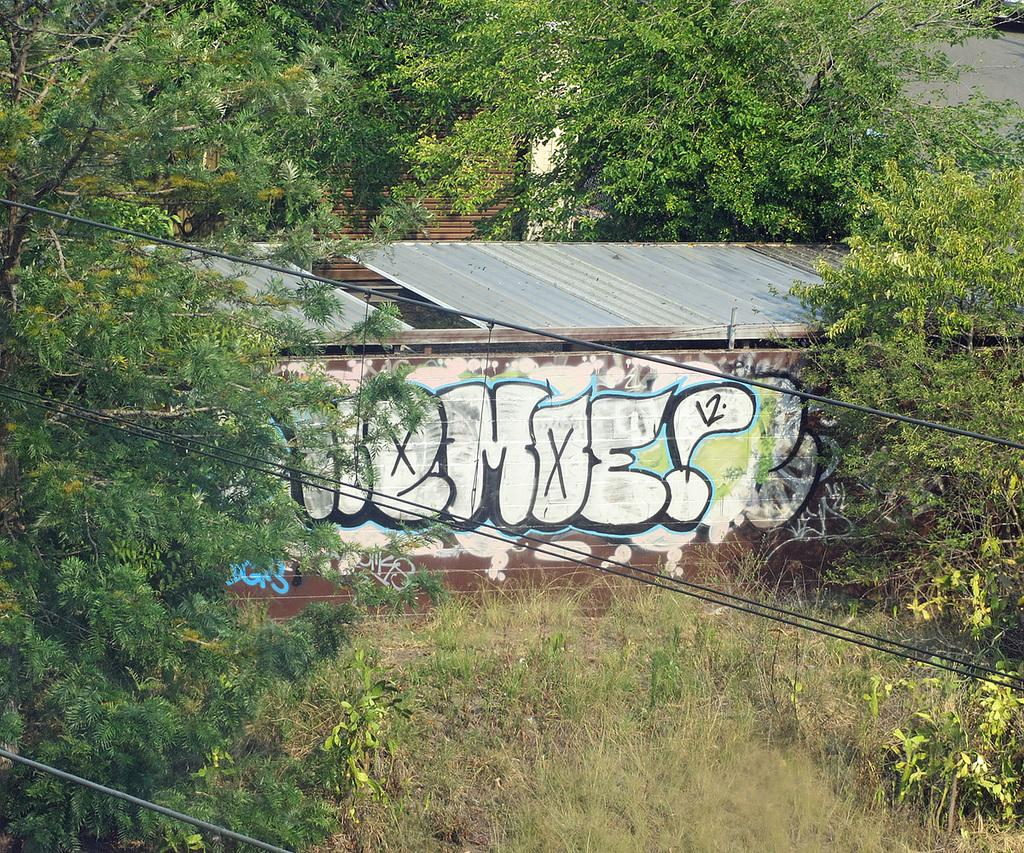What type of objects can be seen in the image? There are cables, plants, and trees in the image. Can you describe the painting in the image? There is a painting on a wall in the image. What type of paste is used to hold the plants in the image? There is no paste visible in the image, and it is not mentioned that the plants are being held in place. 